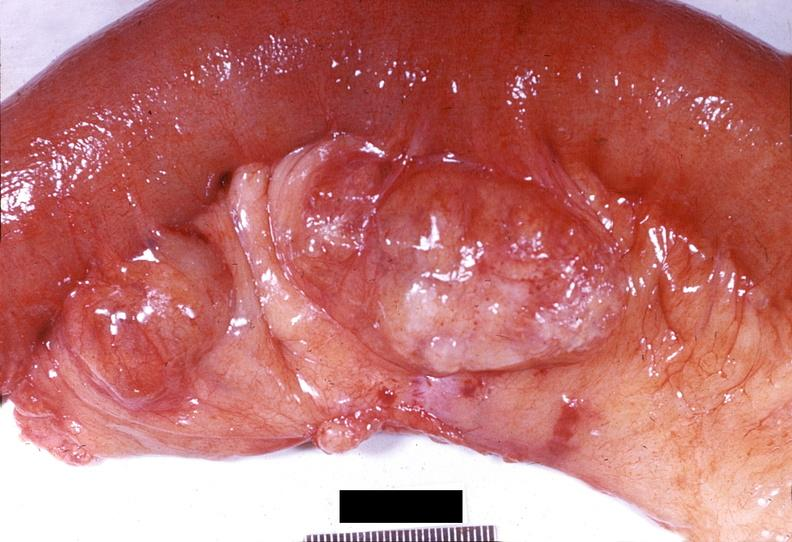what does this image show?
Answer the question using a single word or phrase. Gejunum 